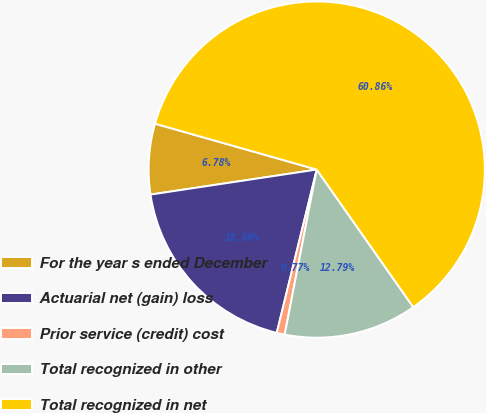Convert chart. <chart><loc_0><loc_0><loc_500><loc_500><pie_chart><fcel>For the year s ended December<fcel>Actuarial net (gain) loss<fcel>Prior service (credit) cost<fcel>Total recognized in other<fcel>Total recognized in net<nl><fcel>6.78%<fcel>18.8%<fcel>0.77%<fcel>12.79%<fcel>60.86%<nl></chart> 